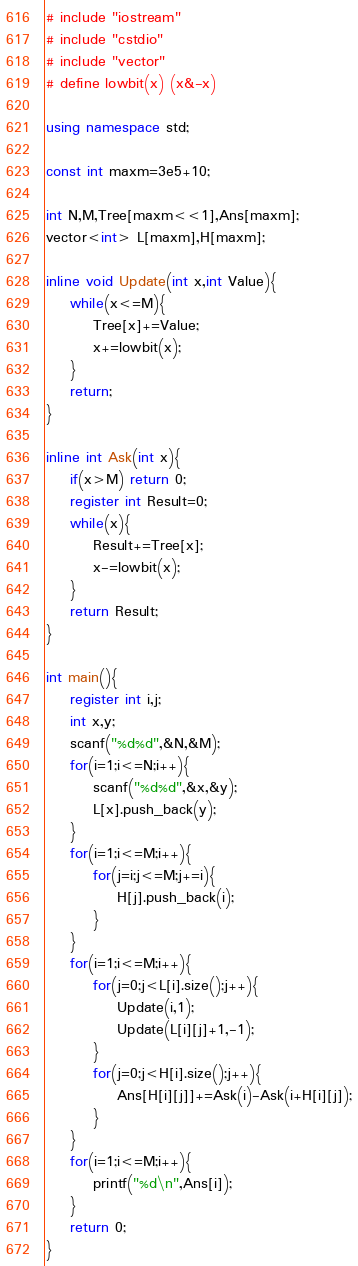<code> <loc_0><loc_0><loc_500><loc_500><_C++_># include "iostream"
# include "cstdio"
# include "vector"
# define lowbit(x) (x&-x)

using namespace std;

const int maxm=3e5+10;

int N,M,Tree[maxm<<1],Ans[maxm];
vector<int> L[maxm],H[maxm];

inline void Update(int x,int Value){
	while(x<=M){
		Tree[x]+=Value;
		x+=lowbit(x);
	}
	return;
}

inline int Ask(int x){
	if(x>M) return 0;
	register int Result=0;
	while(x){
		Result+=Tree[x];
		x-=lowbit(x);
	}
	return Result;
}

int main(){
	register int i,j;
	int x,y;
	scanf("%d%d",&N,&M);
	for(i=1;i<=N;i++){
		scanf("%d%d",&x,&y);
		L[x].push_back(y);
	}
	for(i=1;i<=M;i++){
		for(j=i;j<=M;j+=i){
			H[j].push_back(i);
		}
	}
	for(i=1;i<=M;i++){
		for(j=0;j<L[i].size();j++){
			Update(i,1);
			Update(L[i][j]+1,-1);
		}
		for(j=0;j<H[i].size();j++){
			Ans[H[i][j]]+=Ask(i)-Ask(i+H[i][j]);
		}
	}
	for(i=1;i<=M;i++){
		printf("%d\n",Ans[i]);
	}
	return 0;
}</code> 